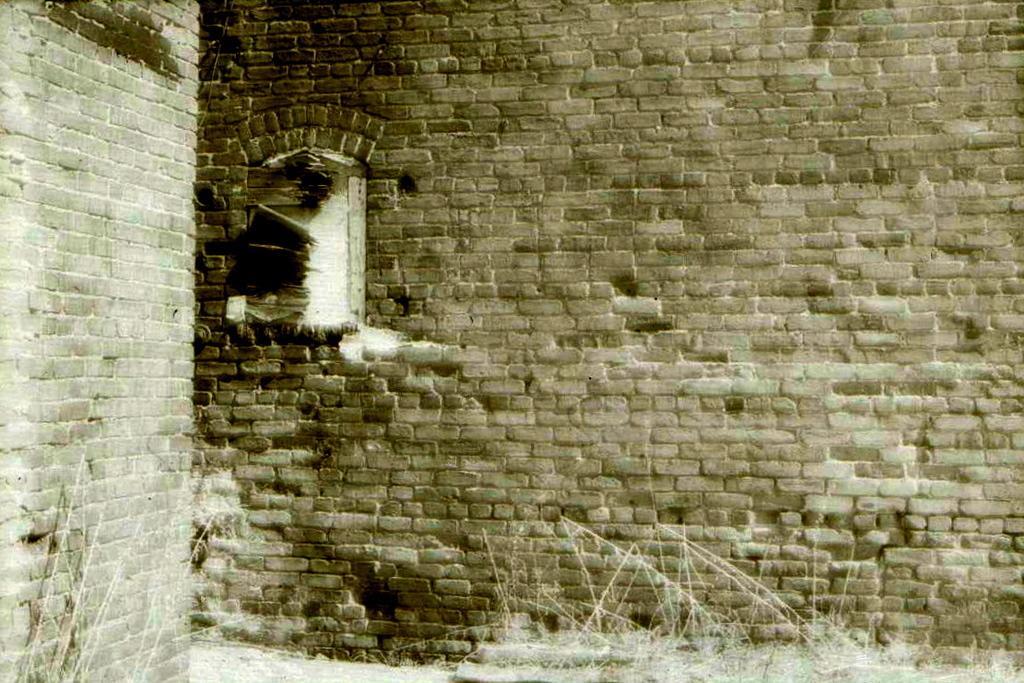In one or two sentences, can you explain what this image depicts? In this picture we can see walls, window and grass. 